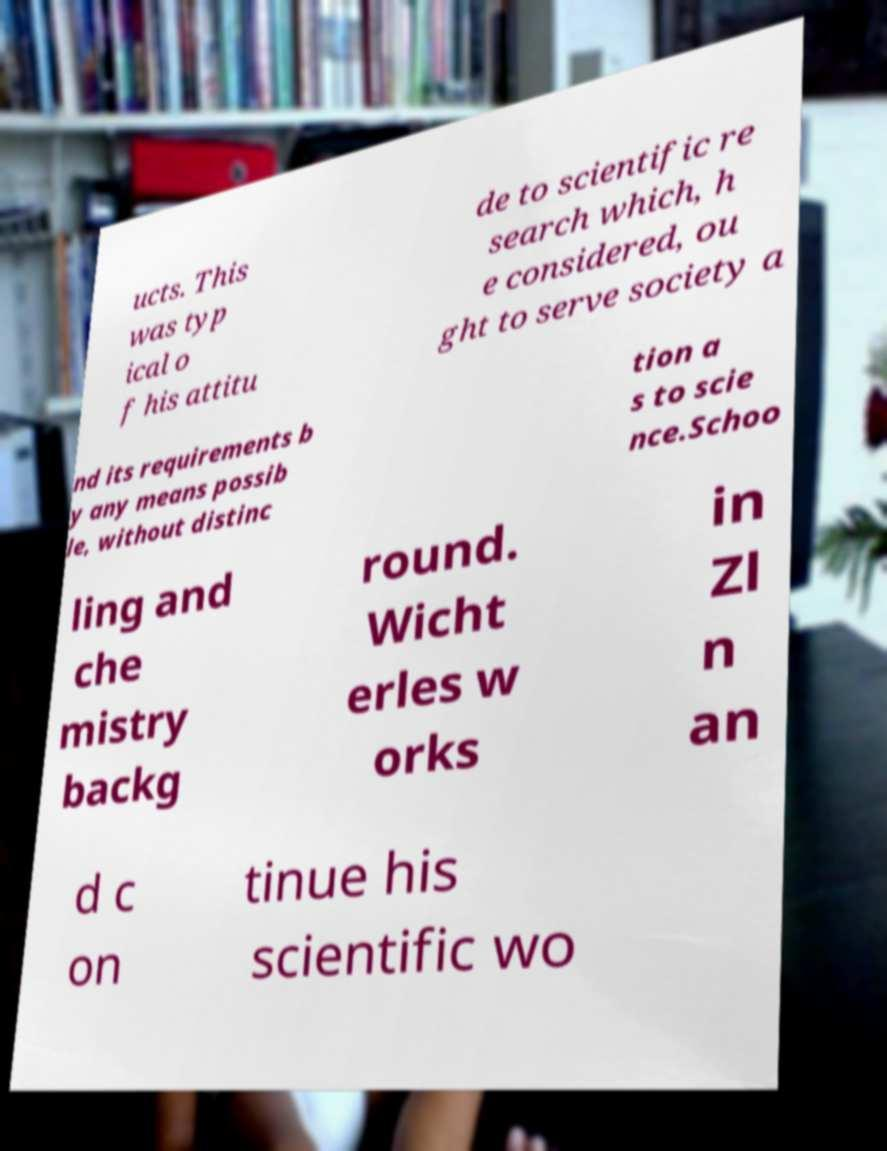What messages or text are displayed in this image? I need them in a readable, typed format. ucts. This was typ ical o f his attitu de to scientific re search which, h e considered, ou ght to serve society a nd its requirements b y any means possib le, without distinc tion a s to scie nce.Schoo ling and che mistry backg round. Wicht erles w orks in Zl n an d c on tinue his scientific wo 